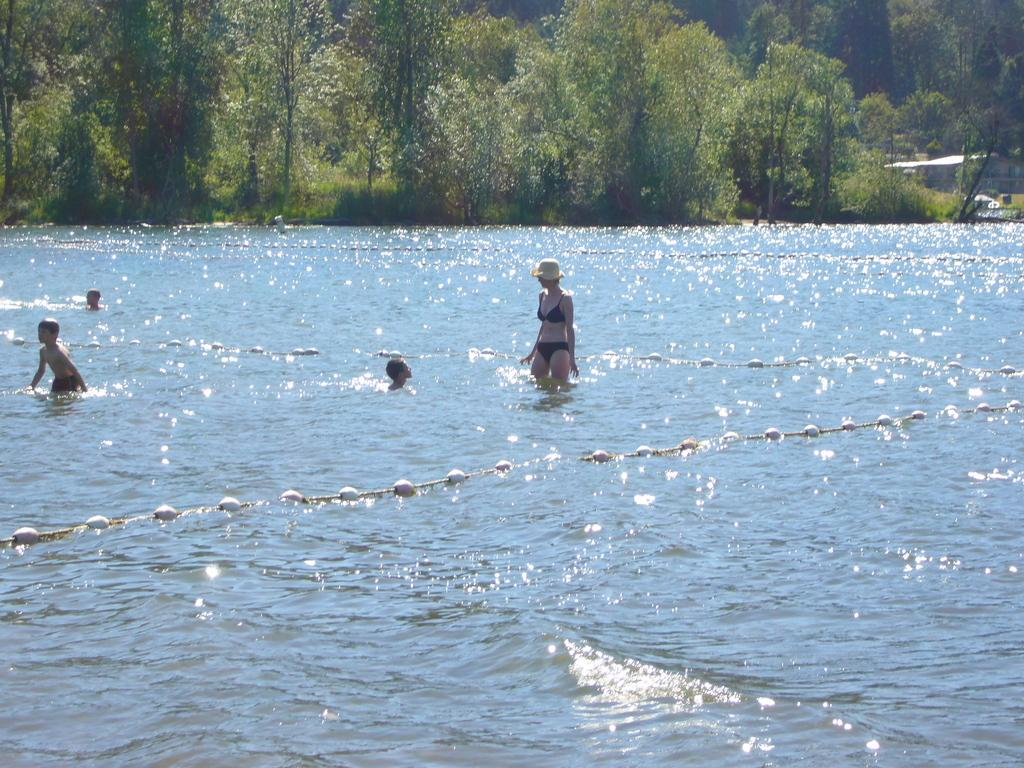What are the people in the image doing? The people in the image are in the water. What can be seen in the background of the image? There are trees in the background of the image. What type of body of water is causing trouble for the people in the image? There is no indication in the image that the people are experiencing any trouble, and the type of body of water is not specified. 